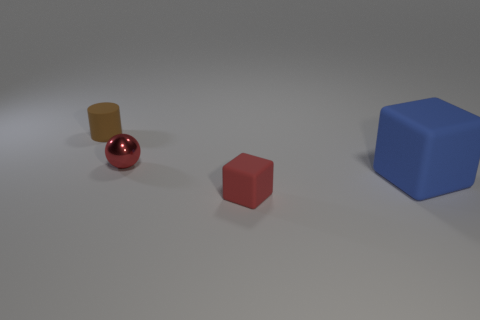Add 3 small shiny spheres. How many objects exist? 7 Add 1 large rubber objects. How many large rubber objects exist? 2 Subtract 0 gray balls. How many objects are left? 4 Subtract all blue things. Subtract all small rubber cylinders. How many objects are left? 2 Add 2 rubber objects. How many rubber objects are left? 5 